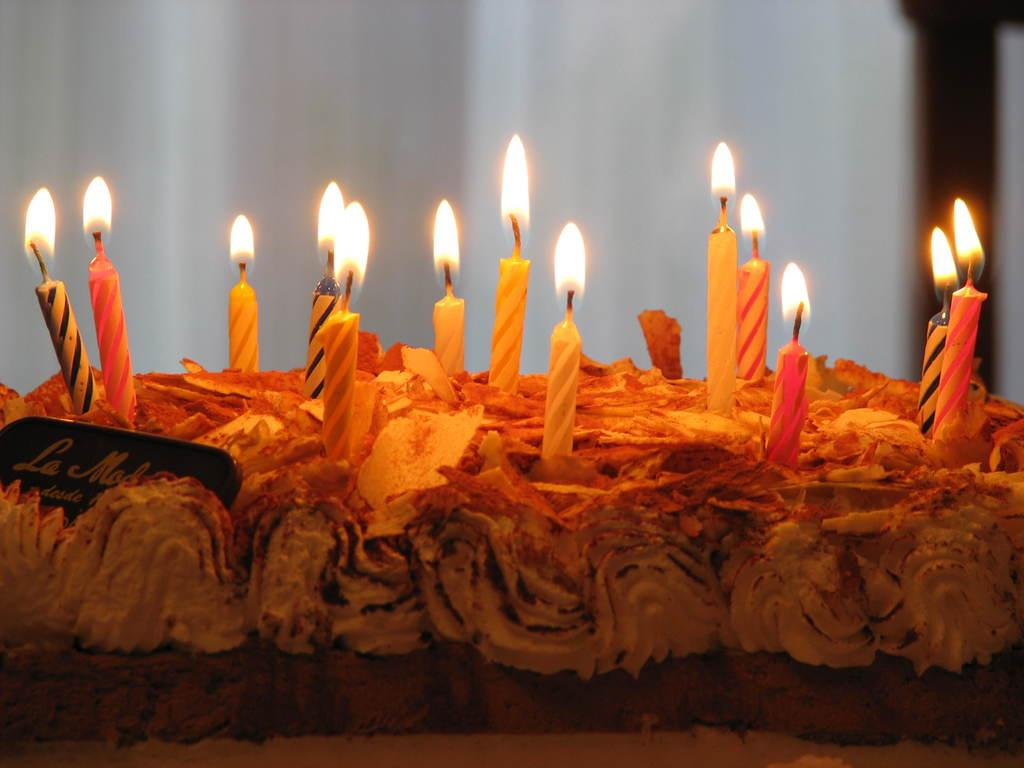What is the main subject of the image? There is a cake in the image. What is placed on top of the cake? There are candles on the cake. What is the state of the candles? The candles are lightened. Can you see a snail playing the guitar on the cake in the image? No, there is no snail or guitar present on the cake in the image. 